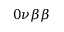Convert formula to latex. <formula><loc_0><loc_0><loc_500><loc_500>0 \nu \beta \beta</formula> 